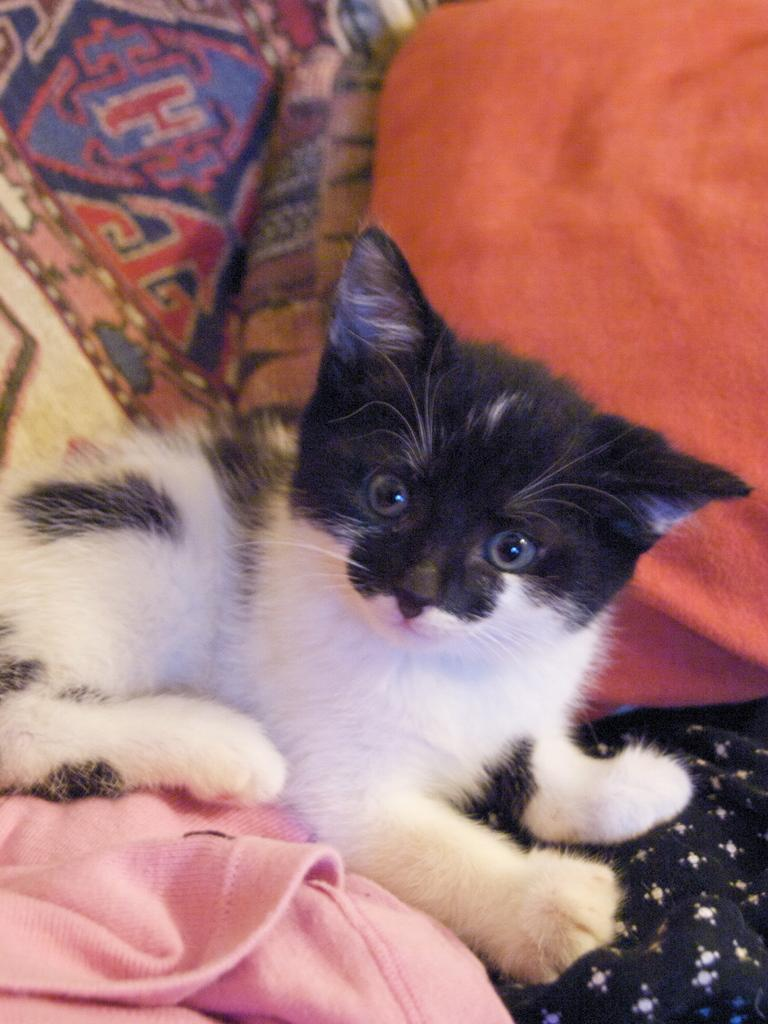What type of animal is in the image? There is a cat in the image. What is the cat doing in the image? The cat is laying down. What else can be seen in the background of the image? There are clothes visible in the background of the image. Can you see a fan in the image? There is no fan present in the image. What type of terrain is visible at the seashore in the image? There is no seashore present in the image; it features a cat laying down and clothes in the background. 